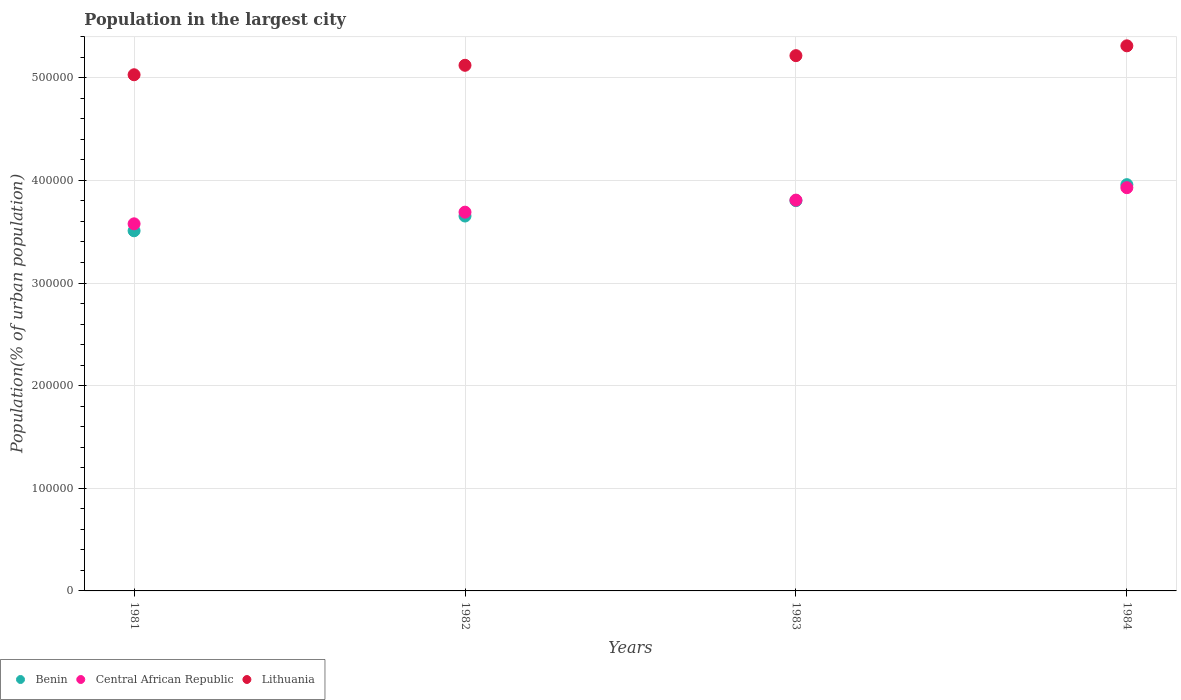Is the number of dotlines equal to the number of legend labels?
Provide a succinct answer. Yes. What is the population in the largest city in Central African Republic in 1982?
Your answer should be compact. 3.69e+05. Across all years, what is the maximum population in the largest city in Benin?
Provide a succinct answer. 3.96e+05. Across all years, what is the minimum population in the largest city in Benin?
Provide a short and direct response. 3.51e+05. In which year was the population in the largest city in Central African Republic minimum?
Provide a succinct answer. 1981. What is the total population in the largest city in Benin in the graph?
Offer a terse response. 1.49e+06. What is the difference between the population in the largest city in Benin in 1982 and that in 1983?
Offer a terse response. -1.50e+04. What is the difference between the population in the largest city in Benin in 1983 and the population in the largest city in Lithuania in 1981?
Your response must be concise. -1.23e+05. What is the average population in the largest city in Lithuania per year?
Give a very brief answer. 5.17e+05. In the year 1983, what is the difference between the population in the largest city in Central African Republic and population in the largest city in Lithuania?
Your answer should be very brief. -1.41e+05. In how many years, is the population in the largest city in Central African Republic greater than 380000 %?
Ensure brevity in your answer.  2. What is the ratio of the population in the largest city in Benin in 1983 to that in 1984?
Your answer should be compact. 0.96. Is the population in the largest city in Lithuania in 1981 less than that in 1984?
Give a very brief answer. Yes. Is the difference between the population in the largest city in Central African Republic in 1982 and 1984 greater than the difference between the population in the largest city in Lithuania in 1982 and 1984?
Your answer should be very brief. No. What is the difference between the highest and the second highest population in the largest city in Lithuania?
Offer a very short reply. 9578. What is the difference between the highest and the lowest population in the largest city in Lithuania?
Your response must be concise. 2.82e+04. In how many years, is the population in the largest city in Benin greater than the average population in the largest city in Benin taken over all years?
Give a very brief answer. 2. Is the sum of the population in the largest city in Benin in 1981 and 1983 greater than the maximum population in the largest city in Central African Republic across all years?
Give a very brief answer. Yes. Does the population in the largest city in Lithuania monotonically increase over the years?
Offer a terse response. Yes. Is the population in the largest city in Benin strictly greater than the population in the largest city in Lithuania over the years?
Provide a succinct answer. No. What is the difference between two consecutive major ticks on the Y-axis?
Offer a terse response. 1.00e+05. Does the graph contain any zero values?
Offer a terse response. No. Where does the legend appear in the graph?
Make the answer very short. Bottom left. What is the title of the graph?
Keep it short and to the point. Population in the largest city. Does "Morocco" appear as one of the legend labels in the graph?
Make the answer very short. No. What is the label or title of the Y-axis?
Keep it short and to the point. Population(% of urban population). What is the Population(% of urban population) in Benin in 1981?
Keep it short and to the point. 3.51e+05. What is the Population(% of urban population) in Central African Republic in 1981?
Provide a succinct answer. 3.58e+05. What is the Population(% of urban population) of Lithuania in 1981?
Make the answer very short. 5.03e+05. What is the Population(% of urban population) of Benin in 1982?
Your response must be concise. 3.65e+05. What is the Population(% of urban population) of Central African Republic in 1982?
Offer a very short reply. 3.69e+05. What is the Population(% of urban population) in Lithuania in 1982?
Give a very brief answer. 5.12e+05. What is the Population(% of urban population) in Benin in 1983?
Keep it short and to the point. 3.80e+05. What is the Population(% of urban population) of Central African Republic in 1983?
Your answer should be very brief. 3.81e+05. What is the Population(% of urban population) in Lithuania in 1983?
Provide a succinct answer. 5.22e+05. What is the Population(% of urban population) of Benin in 1984?
Provide a succinct answer. 3.96e+05. What is the Population(% of urban population) in Central African Republic in 1984?
Offer a very short reply. 3.93e+05. What is the Population(% of urban population) of Lithuania in 1984?
Give a very brief answer. 5.31e+05. Across all years, what is the maximum Population(% of urban population) of Benin?
Offer a terse response. 3.96e+05. Across all years, what is the maximum Population(% of urban population) in Central African Republic?
Provide a short and direct response. 3.93e+05. Across all years, what is the maximum Population(% of urban population) in Lithuania?
Offer a terse response. 5.31e+05. Across all years, what is the minimum Population(% of urban population) in Benin?
Your answer should be compact. 3.51e+05. Across all years, what is the minimum Population(% of urban population) in Central African Republic?
Your answer should be very brief. 3.58e+05. Across all years, what is the minimum Population(% of urban population) in Lithuania?
Provide a short and direct response. 5.03e+05. What is the total Population(% of urban population) of Benin in the graph?
Your response must be concise. 1.49e+06. What is the total Population(% of urban population) in Central African Republic in the graph?
Offer a very short reply. 1.50e+06. What is the total Population(% of urban population) of Lithuania in the graph?
Make the answer very short. 2.07e+06. What is the difference between the Population(% of urban population) of Benin in 1981 and that in 1982?
Offer a terse response. -1.44e+04. What is the difference between the Population(% of urban population) in Central African Republic in 1981 and that in 1982?
Offer a terse response. -1.14e+04. What is the difference between the Population(% of urban population) in Lithuania in 1981 and that in 1982?
Your answer should be compact. -9224. What is the difference between the Population(% of urban population) of Benin in 1981 and that in 1983?
Your answer should be very brief. -2.93e+04. What is the difference between the Population(% of urban population) of Central African Republic in 1981 and that in 1983?
Ensure brevity in your answer.  -2.31e+04. What is the difference between the Population(% of urban population) in Lithuania in 1981 and that in 1983?
Your answer should be compact. -1.86e+04. What is the difference between the Population(% of urban population) of Benin in 1981 and that in 1984?
Provide a succinct answer. -4.49e+04. What is the difference between the Population(% of urban population) in Central African Republic in 1981 and that in 1984?
Offer a very short reply. -3.52e+04. What is the difference between the Population(% of urban population) in Lithuania in 1981 and that in 1984?
Your answer should be very brief. -2.82e+04. What is the difference between the Population(% of urban population) in Benin in 1982 and that in 1983?
Your response must be concise. -1.50e+04. What is the difference between the Population(% of urban population) of Central African Republic in 1982 and that in 1983?
Your answer should be very brief. -1.17e+04. What is the difference between the Population(% of urban population) in Lithuania in 1982 and that in 1983?
Give a very brief answer. -9392. What is the difference between the Population(% of urban population) in Benin in 1982 and that in 1984?
Your answer should be compact. -3.06e+04. What is the difference between the Population(% of urban population) of Central African Republic in 1982 and that in 1984?
Ensure brevity in your answer.  -2.39e+04. What is the difference between the Population(% of urban population) of Lithuania in 1982 and that in 1984?
Provide a short and direct response. -1.90e+04. What is the difference between the Population(% of urban population) in Benin in 1983 and that in 1984?
Ensure brevity in your answer.  -1.56e+04. What is the difference between the Population(% of urban population) of Central African Republic in 1983 and that in 1984?
Your response must be concise. -1.21e+04. What is the difference between the Population(% of urban population) of Lithuania in 1983 and that in 1984?
Offer a terse response. -9578. What is the difference between the Population(% of urban population) of Benin in 1981 and the Population(% of urban population) of Central African Republic in 1982?
Offer a terse response. -1.81e+04. What is the difference between the Population(% of urban population) of Benin in 1981 and the Population(% of urban population) of Lithuania in 1982?
Make the answer very short. -1.61e+05. What is the difference between the Population(% of urban population) of Central African Republic in 1981 and the Population(% of urban population) of Lithuania in 1982?
Your answer should be very brief. -1.54e+05. What is the difference between the Population(% of urban population) in Benin in 1981 and the Population(% of urban population) in Central African Republic in 1983?
Keep it short and to the point. -2.99e+04. What is the difference between the Population(% of urban population) of Benin in 1981 and the Population(% of urban population) of Lithuania in 1983?
Provide a succinct answer. -1.71e+05. What is the difference between the Population(% of urban population) in Central African Republic in 1981 and the Population(% of urban population) in Lithuania in 1983?
Ensure brevity in your answer.  -1.64e+05. What is the difference between the Population(% of urban population) in Benin in 1981 and the Population(% of urban population) in Central African Republic in 1984?
Make the answer very short. -4.20e+04. What is the difference between the Population(% of urban population) in Benin in 1981 and the Population(% of urban population) in Lithuania in 1984?
Your response must be concise. -1.80e+05. What is the difference between the Population(% of urban population) of Central African Republic in 1981 and the Population(% of urban population) of Lithuania in 1984?
Make the answer very short. -1.73e+05. What is the difference between the Population(% of urban population) in Benin in 1982 and the Population(% of urban population) in Central African Republic in 1983?
Your answer should be compact. -1.55e+04. What is the difference between the Population(% of urban population) of Benin in 1982 and the Population(% of urban population) of Lithuania in 1983?
Offer a very short reply. -1.56e+05. What is the difference between the Population(% of urban population) in Central African Republic in 1982 and the Population(% of urban population) in Lithuania in 1983?
Your response must be concise. -1.52e+05. What is the difference between the Population(% of urban population) in Benin in 1982 and the Population(% of urban population) in Central African Republic in 1984?
Make the answer very short. -2.76e+04. What is the difference between the Population(% of urban population) of Benin in 1982 and the Population(% of urban population) of Lithuania in 1984?
Make the answer very short. -1.66e+05. What is the difference between the Population(% of urban population) of Central African Republic in 1982 and the Population(% of urban population) of Lithuania in 1984?
Offer a terse response. -1.62e+05. What is the difference between the Population(% of urban population) in Benin in 1983 and the Population(% of urban population) in Central African Republic in 1984?
Your answer should be very brief. -1.27e+04. What is the difference between the Population(% of urban population) of Benin in 1983 and the Population(% of urban population) of Lithuania in 1984?
Your response must be concise. -1.51e+05. What is the difference between the Population(% of urban population) in Central African Republic in 1983 and the Population(% of urban population) in Lithuania in 1984?
Provide a succinct answer. -1.50e+05. What is the average Population(% of urban population) of Benin per year?
Your answer should be compact. 3.73e+05. What is the average Population(% of urban population) of Central African Republic per year?
Your answer should be compact. 3.75e+05. What is the average Population(% of urban population) of Lithuania per year?
Your answer should be compact. 5.17e+05. In the year 1981, what is the difference between the Population(% of urban population) of Benin and Population(% of urban population) of Central African Republic?
Offer a terse response. -6778. In the year 1981, what is the difference between the Population(% of urban population) of Benin and Population(% of urban population) of Lithuania?
Your answer should be compact. -1.52e+05. In the year 1981, what is the difference between the Population(% of urban population) in Central African Republic and Population(% of urban population) in Lithuania?
Your answer should be compact. -1.45e+05. In the year 1982, what is the difference between the Population(% of urban population) of Benin and Population(% of urban population) of Central African Republic?
Provide a succinct answer. -3770. In the year 1982, what is the difference between the Population(% of urban population) of Benin and Population(% of urban population) of Lithuania?
Provide a succinct answer. -1.47e+05. In the year 1982, what is the difference between the Population(% of urban population) of Central African Republic and Population(% of urban population) of Lithuania?
Ensure brevity in your answer.  -1.43e+05. In the year 1983, what is the difference between the Population(% of urban population) of Benin and Population(% of urban population) of Central African Republic?
Provide a succinct answer. -536. In the year 1983, what is the difference between the Population(% of urban population) in Benin and Population(% of urban population) in Lithuania?
Provide a short and direct response. -1.41e+05. In the year 1983, what is the difference between the Population(% of urban population) of Central African Republic and Population(% of urban population) of Lithuania?
Provide a succinct answer. -1.41e+05. In the year 1984, what is the difference between the Population(% of urban population) of Benin and Population(% of urban population) of Central African Republic?
Provide a short and direct response. 2944. In the year 1984, what is the difference between the Population(% of urban population) of Benin and Population(% of urban population) of Lithuania?
Give a very brief answer. -1.35e+05. In the year 1984, what is the difference between the Population(% of urban population) in Central African Republic and Population(% of urban population) in Lithuania?
Your response must be concise. -1.38e+05. What is the ratio of the Population(% of urban population) of Benin in 1981 to that in 1982?
Offer a very short reply. 0.96. What is the ratio of the Population(% of urban population) in Central African Republic in 1981 to that in 1982?
Keep it short and to the point. 0.97. What is the ratio of the Population(% of urban population) of Benin in 1981 to that in 1983?
Make the answer very short. 0.92. What is the ratio of the Population(% of urban population) of Central African Republic in 1981 to that in 1983?
Your answer should be very brief. 0.94. What is the ratio of the Population(% of urban population) of Lithuania in 1981 to that in 1983?
Make the answer very short. 0.96. What is the ratio of the Population(% of urban population) in Benin in 1981 to that in 1984?
Your response must be concise. 0.89. What is the ratio of the Population(% of urban population) of Central African Republic in 1981 to that in 1984?
Your answer should be compact. 0.91. What is the ratio of the Population(% of urban population) of Lithuania in 1981 to that in 1984?
Ensure brevity in your answer.  0.95. What is the ratio of the Population(% of urban population) in Benin in 1982 to that in 1983?
Provide a short and direct response. 0.96. What is the ratio of the Population(% of urban population) in Central African Republic in 1982 to that in 1983?
Keep it short and to the point. 0.97. What is the ratio of the Population(% of urban population) in Lithuania in 1982 to that in 1983?
Make the answer very short. 0.98. What is the ratio of the Population(% of urban population) in Benin in 1982 to that in 1984?
Give a very brief answer. 0.92. What is the ratio of the Population(% of urban population) in Central African Republic in 1982 to that in 1984?
Keep it short and to the point. 0.94. What is the ratio of the Population(% of urban population) in Lithuania in 1982 to that in 1984?
Keep it short and to the point. 0.96. What is the ratio of the Population(% of urban population) of Benin in 1983 to that in 1984?
Your response must be concise. 0.96. What is the ratio of the Population(% of urban population) of Central African Republic in 1983 to that in 1984?
Give a very brief answer. 0.97. What is the ratio of the Population(% of urban population) in Lithuania in 1983 to that in 1984?
Give a very brief answer. 0.98. What is the difference between the highest and the second highest Population(% of urban population) in Benin?
Offer a terse response. 1.56e+04. What is the difference between the highest and the second highest Population(% of urban population) of Central African Republic?
Offer a very short reply. 1.21e+04. What is the difference between the highest and the second highest Population(% of urban population) in Lithuania?
Your answer should be very brief. 9578. What is the difference between the highest and the lowest Population(% of urban population) in Benin?
Ensure brevity in your answer.  4.49e+04. What is the difference between the highest and the lowest Population(% of urban population) of Central African Republic?
Provide a short and direct response. 3.52e+04. What is the difference between the highest and the lowest Population(% of urban population) of Lithuania?
Your answer should be compact. 2.82e+04. 